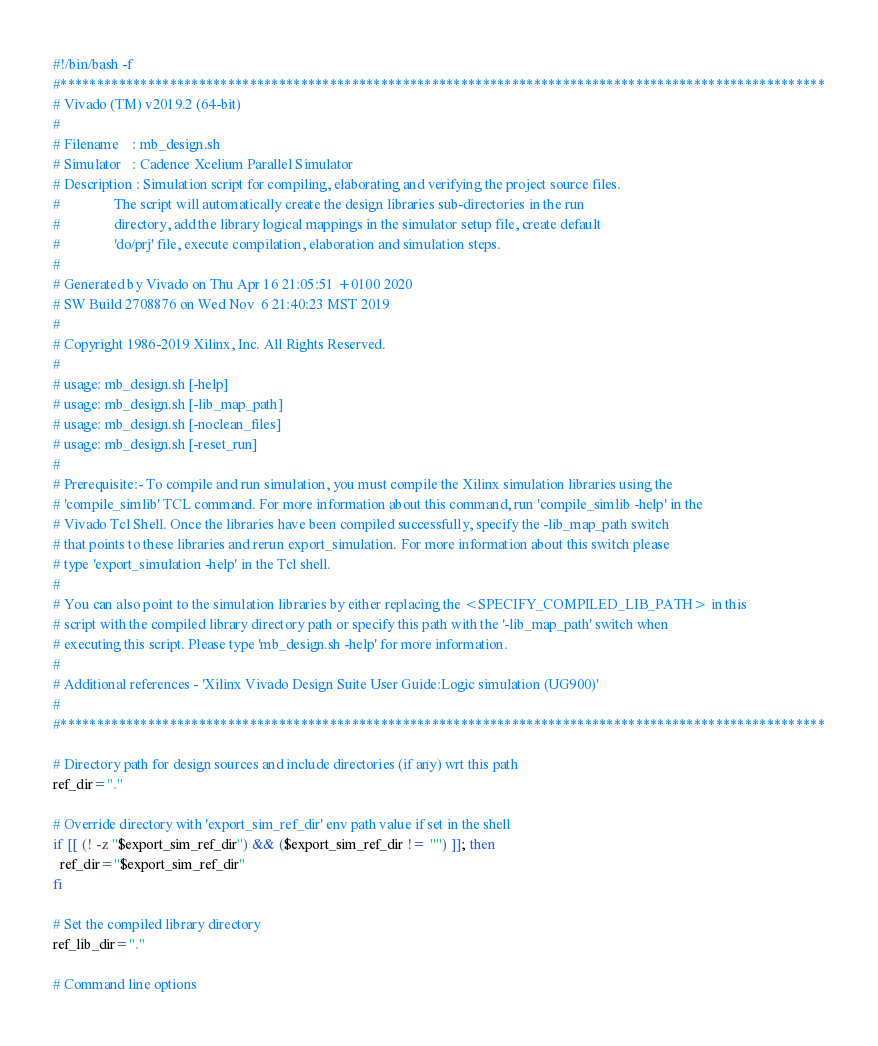Convert code to text. <code><loc_0><loc_0><loc_500><loc_500><_Bash_>#!/bin/bash -f
#*********************************************************************************************************
# Vivado (TM) v2019.2 (64-bit)
#
# Filename    : mb_design.sh
# Simulator   : Cadence Xcelium Parallel Simulator
# Description : Simulation script for compiling, elaborating and verifying the project source files.
#               The script will automatically create the design libraries sub-directories in the run
#               directory, add the library logical mappings in the simulator setup file, create default
#               'do/prj' file, execute compilation, elaboration and simulation steps.
#
# Generated by Vivado on Thu Apr 16 21:05:51 +0100 2020
# SW Build 2708876 on Wed Nov  6 21:40:23 MST 2019
#
# Copyright 1986-2019 Xilinx, Inc. All Rights Reserved. 
#
# usage: mb_design.sh [-help]
# usage: mb_design.sh [-lib_map_path]
# usage: mb_design.sh [-noclean_files]
# usage: mb_design.sh [-reset_run]
#
# Prerequisite:- To compile and run simulation, you must compile the Xilinx simulation libraries using the
# 'compile_simlib' TCL command. For more information about this command, run 'compile_simlib -help' in the
# Vivado Tcl Shell. Once the libraries have been compiled successfully, specify the -lib_map_path switch
# that points to these libraries and rerun export_simulation. For more information about this switch please
# type 'export_simulation -help' in the Tcl shell.
#
# You can also point to the simulation libraries by either replacing the <SPECIFY_COMPILED_LIB_PATH> in this
# script with the compiled library directory path or specify this path with the '-lib_map_path' switch when
# executing this script. Please type 'mb_design.sh -help' for more information.
#
# Additional references - 'Xilinx Vivado Design Suite User Guide:Logic simulation (UG900)'
#
#*********************************************************************************************************

# Directory path for design sources and include directories (if any) wrt this path
ref_dir="."

# Override directory with 'export_sim_ref_dir' env path value if set in the shell
if [[ (! -z "$export_sim_ref_dir") && ($export_sim_ref_dir != "") ]]; then
  ref_dir="$export_sim_ref_dir"
fi

# Set the compiled library directory
ref_lib_dir="."

# Command line options</code> 